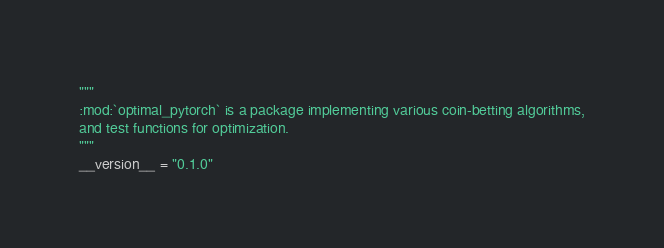<code> <loc_0><loc_0><loc_500><loc_500><_Python_>"""
:mod:`optimal_pytorch` is a package implementing various coin-betting algorithms,
and test functions for optimization.
"""
__version__ = "0.1.0"
</code> 